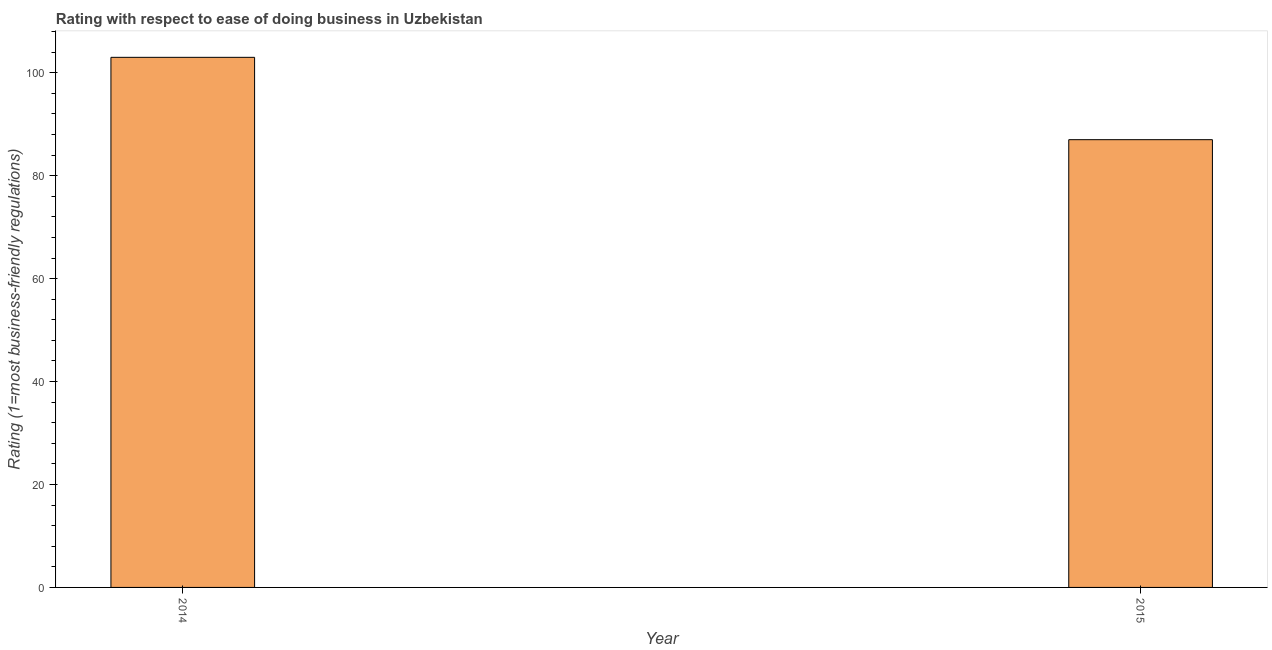Does the graph contain any zero values?
Make the answer very short. No. Does the graph contain grids?
Make the answer very short. No. What is the title of the graph?
Your answer should be compact. Rating with respect to ease of doing business in Uzbekistan. What is the label or title of the Y-axis?
Give a very brief answer. Rating (1=most business-friendly regulations). What is the ease of doing business index in 2014?
Make the answer very short. 103. Across all years, what is the maximum ease of doing business index?
Your answer should be compact. 103. In which year was the ease of doing business index minimum?
Provide a short and direct response. 2015. What is the sum of the ease of doing business index?
Keep it short and to the point. 190. What is the median ease of doing business index?
Give a very brief answer. 95. In how many years, is the ease of doing business index greater than 60 ?
Give a very brief answer. 2. What is the ratio of the ease of doing business index in 2014 to that in 2015?
Make the answer very short. 1.18. What is the difference between two consecutive major ticks on the Y-axis?
Give a very brief answer. 20. What is the Rating (1=most business-friendly regulations) in 2014?
Make the answer very short. 103. What is the Rating (1=most business-friendly regulations) in 2015?
Give a very brief answer. 87. What is the ratio of the Rating (1=most business-friendly regulations) in 2014 to that in 2015?
Your answer should be very brief. 1.18. 